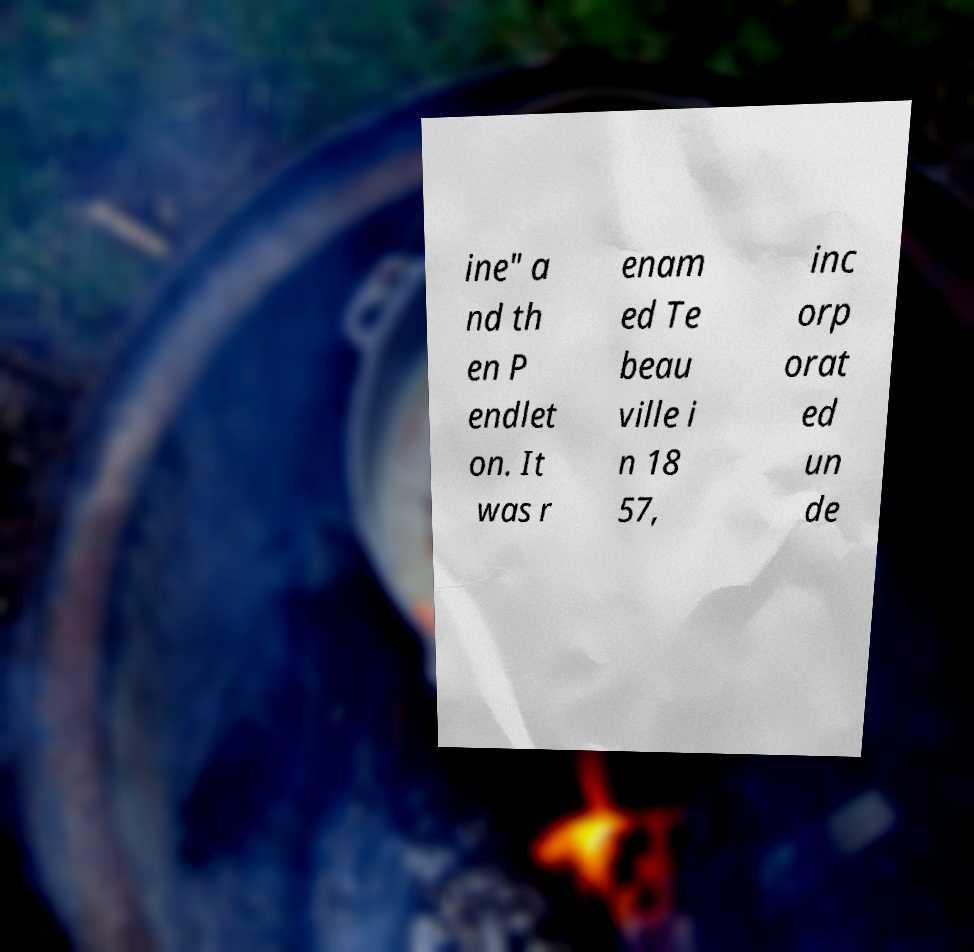There's text embedded in this image that I need extracted. Can you transcribe it verbatim? ine" a nd th en P endlet on. It was r enam ed Te beau ville i n 18 57, inc orp orat ed un de 